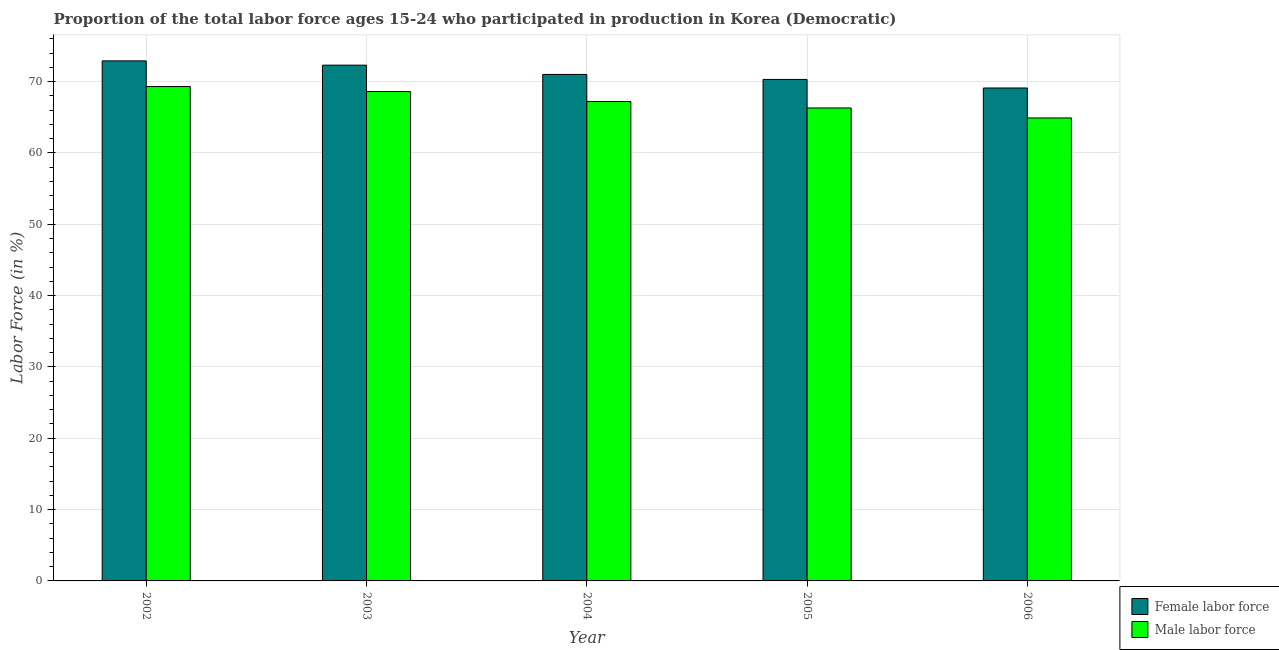How many different coloured bars are there?
Offer a terse response. 2. Are the number of bars per tick equal to the number of legend labels?
Make the answer very short. Yes. How many bars are there on the 3rd tick from the left?
Make the answer very short. 2. How many bars are there on the 3rd tick from the right?
Provide a succinct answer. 2. What is the label of the 5th group of bars from the left?
Provide a short and direct response. 2006. In how many cases, is the number of bars for a given year not equal to the number of legend labels?
Provide a short and direct response. 0. What is the percentage of female labor force in 2005?
Keep it short and to the point. 70.3. Across all years, what is the maximum percentage of female labor force?
Provide a short and direct response. 72.9. Across all years, what is the minimum percentage of female labor force?
Your answer should be compact. 69.1. In which year was the percentage of female labor force maximum?
Offer a terse response. 2002. In which year was the percentage of male labour force minimum?
Make the answer very short. 2006. What is the total percentage of male labour force in the graph?
Your answer should be compact. 336.3. What is the difference between the percentage of male labour force in 2002 and that in 2003?
Offer a terse response. 0.7. What is the difference between the percentage of female labor force in 2004 and the percentage of male labour force in 2002?
Offer a very short reply. -1.9. What is the average percentage of female labor force per year?
Ensure brevity in your answer.  71.12. In how many years, is the percentage of female labor force greater than 54 %?
Offer a very short reply. 5. What is the ratio of the percentage of female labor force in 2005 to that in 2006?
Offer a terse response. 1.02. What is the difference between the highest and the second highest percentage of male labour force?
Keep it short and to the point. 0.7. What is the difference between the highest and the lowest percentage of female labor force?
Offer a terse response. 3.8. In how many years, is the percentage of female labor force greater than the average percentage of female labor force taken over all years?
Give a very brief answer. 2. What does the 1st bar from the left in 2002 represents?
Ensure brevity in your answer.  Female labor force. What does the 1st bar from the right in 2002 represents?
Provide a short and direct response. Male labor force. Are all the bars in the graph horizontal?
Your answer should be compact. No. Does the graph contain grids?
Ensure brevity in your answer.  Yes. Where does the legend appear in the graph?
Ensure brevity in your answer.  Bottom right. How many legend labels are there?
Provide a succinct answer. 2. What is the title of the graph?
Offer a terse response. Proportion of the total labor force ages 15-24 who participated in production in Korea (Democratic). Does "Merchandise imports" appear as one of the legend labels in the graph?
Provide a short and direct response. No. What is the label or title of the X-axis?
Keep it short and to the point. Year. What is the Labor Force (in %) in Female labor force in 2002?
Provide a succinct answer. 72.9. What is the Labor Force (in %) of Male labor force in 2002?
Make the answer very short. 69.3. What is the Labor Force (in %) in Female labor force in 2003?
Ensure brevity in your answer.  72.3. What is the Labor Force (in %) of Male labor force in 2003?
Offer a terse response. 68.6. What is the Labor Force (in %) of Female labor force in 2004?
Offer a very short reply. 71. What is the Labor Force (in %) in Male labor force in 2004?
Offer a terse response. 67.2. What is the Labor Force (in %) in Female labor force in 2005?
Your answer should be very brief. 70.3. What is the Labor Force (in %) in Male labor force in 2005?
Provide a succinct answer. 66.3. What is the Labor Force (in %) of Female labor force in 2006?
Provide a succinct answer. 69.1. What is the Labor Force (in %) of Male labor force in 2006?
Your answer should be compact. 64.9. Across all years, what is the maximum Labor Force (in %) of Female labor force?
Your response must be concise. 72.9. Across all years, what is the maximum Labor Force (in %) in Male labor force?
Provide a succinct answer. 69.3. Across all years, what is the minimum Labor Force (in %) in Female labor force?
Keep it short and to the point. 69.1. Across all years, what is the minimum Labor Force (in %) in Male labor force?
Give a very brief answer. 64.9. What is the total Labor Force (in %) in Female labor force in the graph?
Your answer should be very brief. 355.6. What is the total Labor Force (in %) of Male labor force in the graph?
Offer a very short reply. 336.3. What is the difference between the Labor Force (in %) of Female labor force in 2002 and that in 2003?
Provide a succinct answer. 0.6. What is the difference between the Labor Force (in %) of Female labor force in 2002 and that in 2005?
Offer a very short reply. 2.6. What is the difference between the Labor Force (in %) in Female labor force in 2002 and that in 2006?
Offer a terse response. 3.8. What is the difference between the Labor Force (in %) in Female labor force in 2003 and that in 2004?
Make the answer very short. 1.3. What is the difference between the Labor Force (in %) of Female labor force in 2003 and that in 2006?
Keep it short and to the point. 3.2. What is the difference between the Labor Force (in %) in Male labor force in 2003 and that in 2006?
Keep it short and to the point. 3.7. What is the difference between the Labor Force (in %) in Female labor force in 2004 and that in 2005?
Provide a succinct answer. 0.7. What is the difference between the Labor Force (in %) in Female labor force in 2004 and that in 2006?
Your answer should be very brief. 1.9. What is the difference between the Labor Force (in %) of Female labor force in 2002 and the Labor Force (in %) of Male labor force in 2004?
Offer a very short reply. 5.7. What is the difference between the Labor Force (in %) in Female labor force in 2002 and the Labor Force (in %) in Male labor force in 2005?
Your response must be concise. 6.6. What is the difference between the Labor Force (in %) in Female labor force in 2002 and the Labor Force (in %) in Male labor force in 2006?
Offer a very short reply. 8. What is the difference between the Labor Force (in %) in Female labor force in 2003 and the Labor Force (in %) in Male labor force in 2004?
Your response must be concise. 5.1. What is the difference between the Labor Force (in %) of Female labor force in 2003 and the Labor Force (in %) of Male labor force in 2005?
Provide a succinct answer. 6. What is the difference between the Labor Force (in %) in Female labor force in 2004 and the Labor Force (in %) in Male labor force in 2006?
Offer a very short reply. 6.1. What is the average Labor Force (in %) of Female labor force per year?
Provide a short and direct response. 71.12. What is the average Labor Force (in %) of Male labor force per year?
Provide a short and direct response. 67.26. In the year 2002, what is the difference between the Labor Force (in %) in Female labor force and Labor Force (in %) in Male labor force?
Your answer should be compact. 3.6. In the year 2003, what is the difference between the Labor Force (in %) of Female labor force and Labor Force (in %) of Male labor force?
Offer a very short reply. 3.7. In the year 2005, what is the difference between the Labor Force (in %) in Female labor force and Labor Force (in %) in Male labor force?
Ensure brevity in your answer.  4. In the year 2006, what is the difference between the Labor Force (in %) of Female labor force and Labor Force (in %) of Male labor force?
Offer a very short reply. 4.2. What is the ratio of the Labor Force (in %) in Female labor force in 2002 to that in 2003?
Provide a succinct answer. 1.01. What is the ratio of the Labor Force (in %) of Male labor force in 2002 to that in 2003?
Your response must be concise. 1.01. What is the ratio of the Labor Force (in %) in Female labor force in 2002 to that in 2004?
Ensure brevity in your answer.  1.03. What is the ratio of the Labor Force (in %) of Male labor force in 2002 to that in 2004?
Keep it short and to the point. 1.03. What is the ratio of the Labor Force (in %) in Male labor force in 2002 to that in 2005?
Offer a terse response. 1.05. What is the ratio of the Labor Force (in %) in Female labor force in 2002 to that in 2006?
Make the answer very short. 1.05. What is the ratio of the Labor Force (in %) of Male labor force in 2002 to that in 2006?
Provide a short and direct response. 1.07. What is the ratio of the Labor Force (in %) in Female labor force in 2003 to that in 2004?
Your response must be concise. 1.02. What is the ratio of the Labor Force (in %) in Male labor force in 2003 to that in 2004?
Offer a terse response. 1.02. What is the ratio of the Labor Force (in %) of Female labor force in 2003 to that in 2005?
Give a very brief answer. 1.03. What is the ratio of the Labor Force (in %) in Male labor force in 2003 to that in 2005?
Offer a terse response. 1.03. What is the ratio of the Labor Force (in %) of Female labor force in 2003 to that in 2006?
Your response must be concise. 1.05. What is the ratio of the Labor Force (in %) of Male labor force in 2003 to that in 2006?
Ensure brevity in your answer.  1.06. What is the ratio of the Labor Force (in %) of Male labor force in 2004 to that in 2005?
Your answer should be very brief. 1.01. What is the ratio of the Labor Force (in %) of Female labor force in 2004 to that in 2006?
Give a very brief answer. 1.03. What is the ratio of the Labor Force (in %) in Male labor force in 2004 to that in 2006?
Provide a short and direct response. 1.04. What is the ratio of the Labor Force (in %) in Female labor force in 2005 to that in 2006?
Keep it short and to the point. 1.02. What is the ratio of the Labor Force (in %) of Male labor force in 2005 to that in 2006?
Keep it short and to the point. 1.02. What is the difference between the highest and the second highest Labor Force (in %) of Male labor force?
Your answer should be compact. 0.7. 